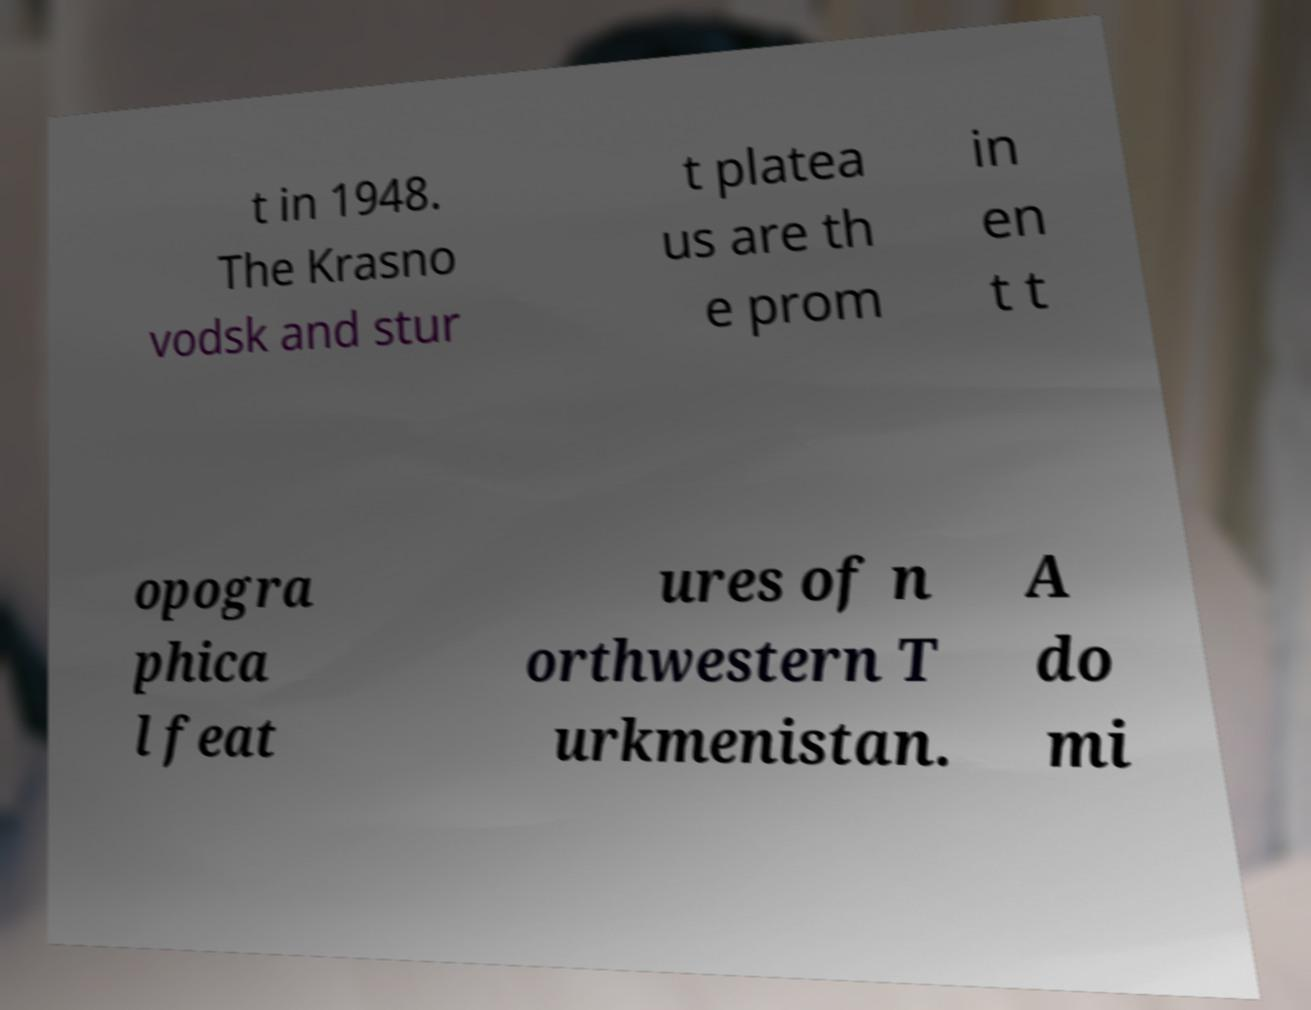For documentation purposes, I need the text within this image transcribed. Could you provide that? t in 1948. The Krasno vodsk and stur t platea us are th e prom in en t t opogra phica l feat ures of n orthwestern T urkmenistan. A do mi 